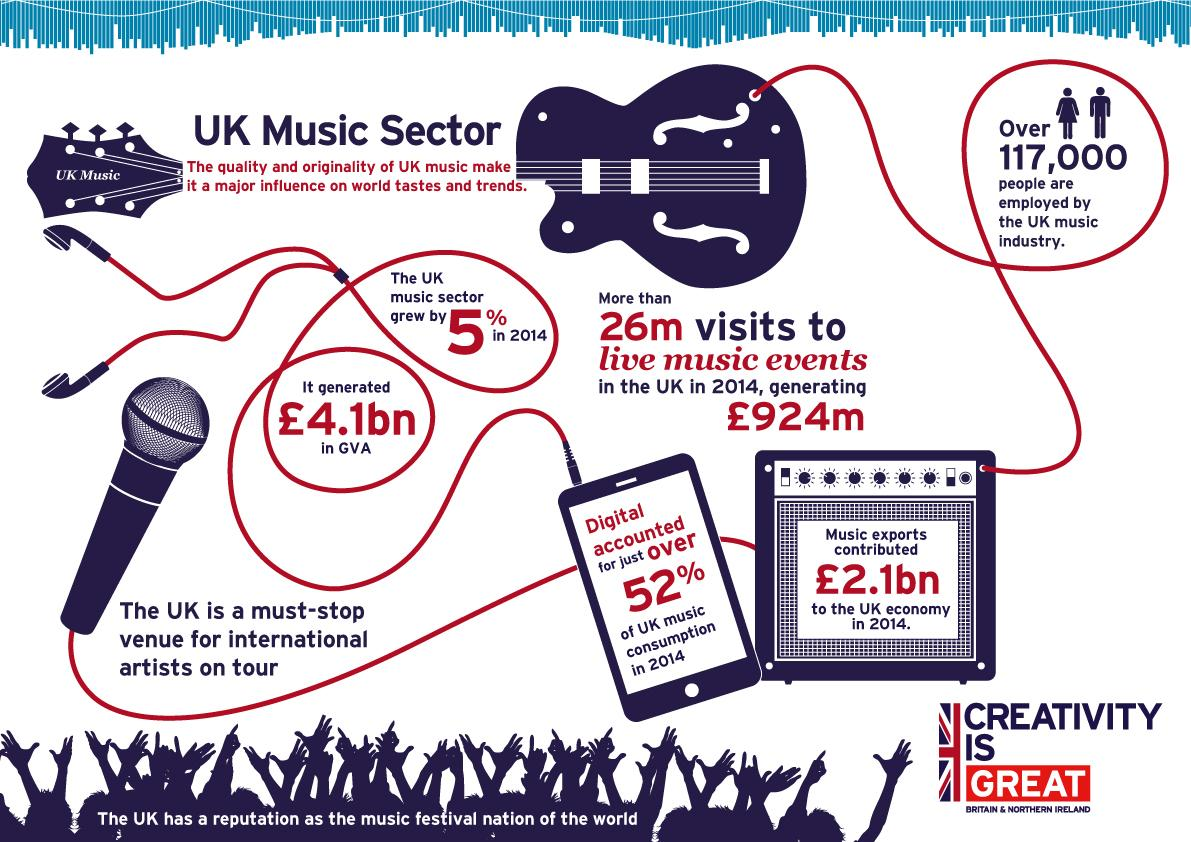Point out several critical features in this image. In the year 2014, the revenue generated by live music events in the United Kingdom was approximately £924 million. In 2014, it is estimated that over 117,000 people were employed by the UK music industry. 